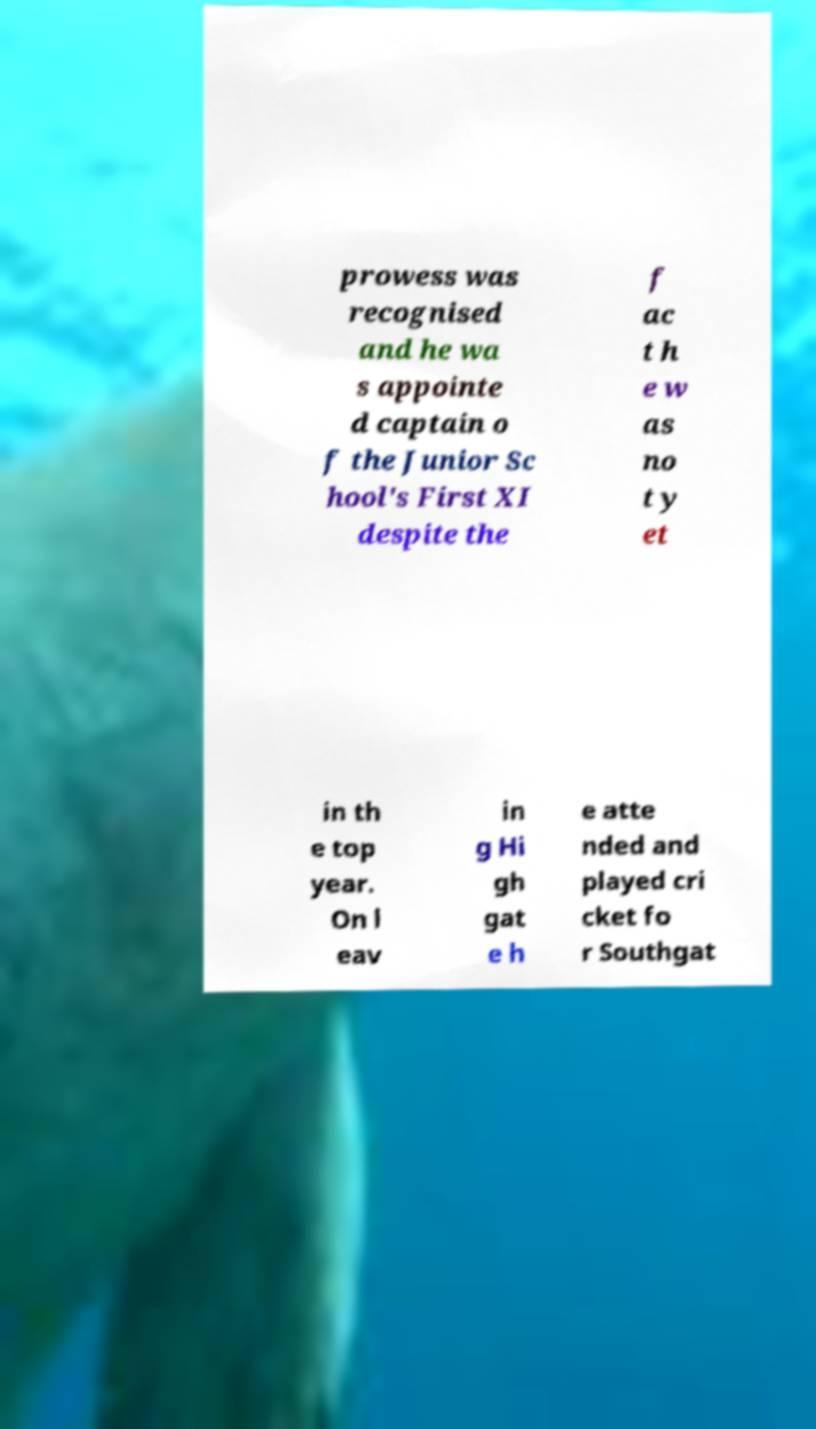Could you extract and type out the text from this image? prowess was recognised and he wa s appointe d captain o f the Junior Sc hool's First XI despite the f ac t h e w as no t y et in th e top year. On l eav in g Hi gh gat e h e atte nded and played cri cket fo r Southgat 